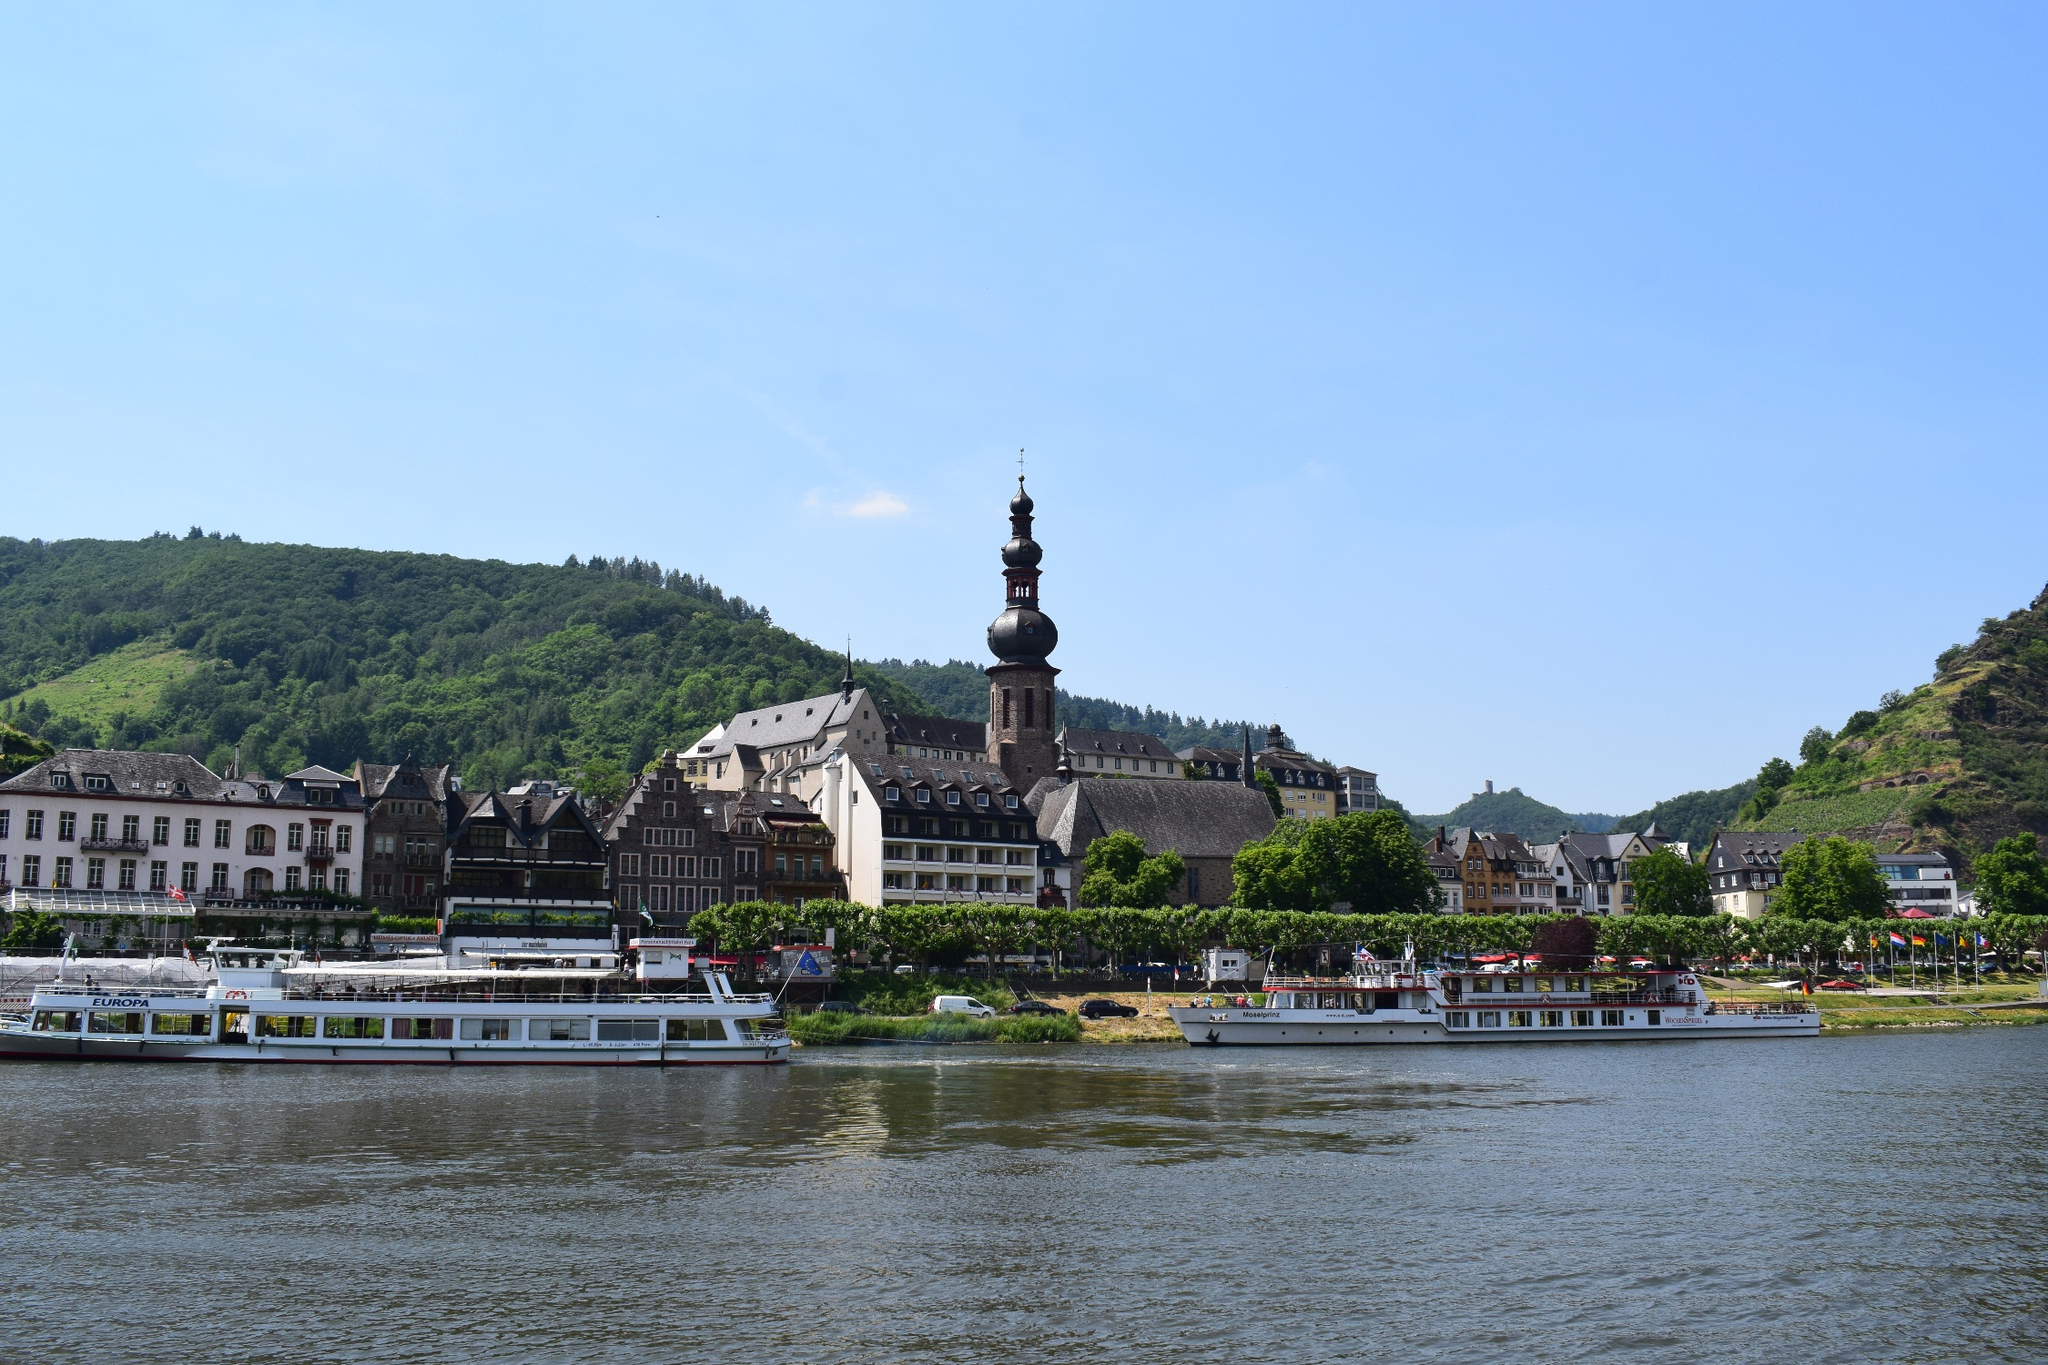What is this photo about? This photo depicts a captivating scene along a river, possibly in a European town. The focal point is a prominent, beautifully constructed building with a distinctive spired clock tower, which appears to be a local landmark or historical building. It is surrounded by other traditional buildings that suggest a quaint, perhaps historic town center. Lush green hills provide a natural backdrop, while a riverboat in the foreground suggests this area is a popular spot for sightseeing tours. The sky is clear and blue, indicating fair weather, which adds to the inviting ambience of the location. This is a place that likely holds significance in local history and culture, inviting visitors to explore its rich architectural and natural beauty. 